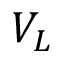Convert formula to latex. <formula><loc_0><loc_0><loc_500><loc_500>V _ { L }</formula> 